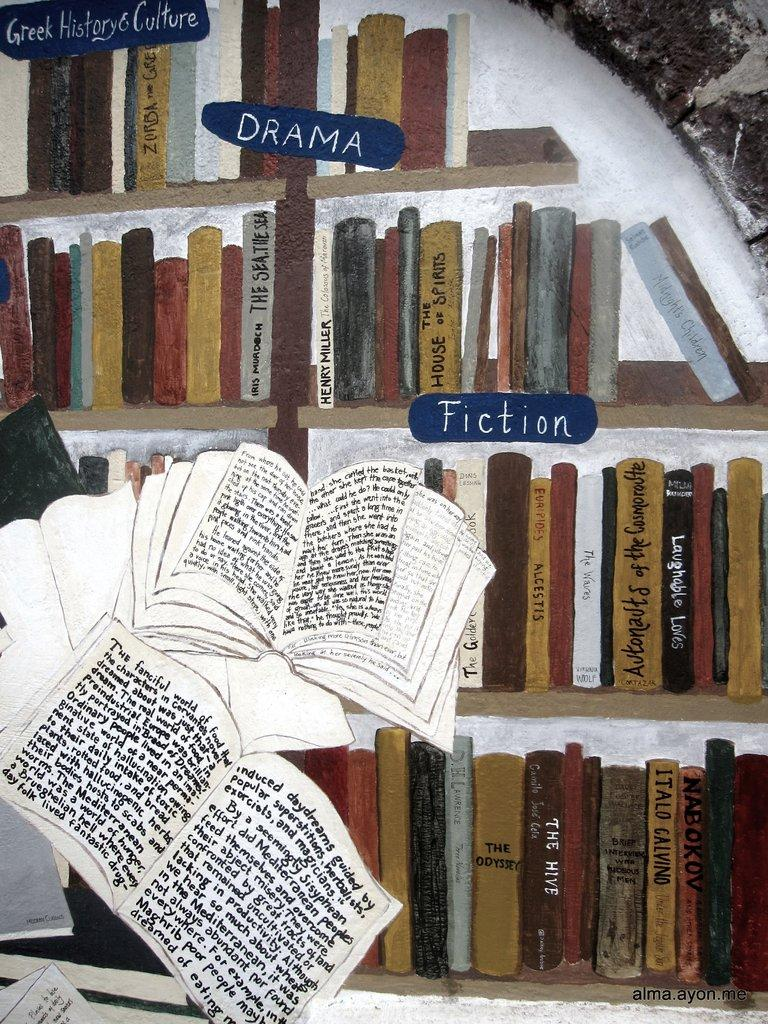What is the main subject of the painting in the image? The main subject of the painting in the image is books. What else can be seen in the image besides the painting? There are many books in a rack in the image. Is there any text or writing on the painting or the books? Yes, there is writing on the painting or the books. Can you hear the voice of the maid in the image? There is no mention of a maid or any voice in the image; it primarily features a painting of books and books in a rack. 